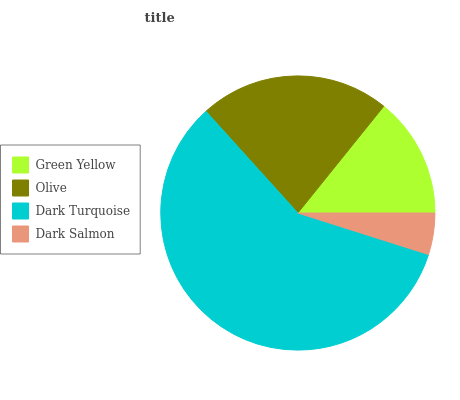Is Dark Salmon the minimum?
Answer yes or no. Yes. Is Dark Turquoise the maximum?
Answer yes or no. Yes. Is Olive the minimum?
Answer yes or no. No. Is Olive the maximum?
Answer yes or no. No. Is Olive greater than Green Yellow?
Answer yes or no. Yes. Is Green Yellow less than Olive?
Answer yes or no. Yes. Is Green Yellow greater than Olive?
Answer yes or no. No. Is Olive less than Green Yellow?
Answer yes or no. No. Is Olive the high median?
Answer yes or no. Yes. Is Green Yellow the low median?
Answer yes or no. Yes. Is Dark Turquoise the high median?
Answer yes or no. No. Is Dark Salmon the low median?
Answer yes or no. No. 